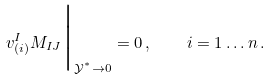Convert formula to latex. <formula><loc_0><loc_0><loc_500><loc_500>v ^ { I } _ { ( i ) } M _ { I J } \Big | _ { \mathcal { Y } ^ { ^ { * } } \rightarrow 0 } = 0 \, , \quad i = 1 \dots n \, .</formula> 